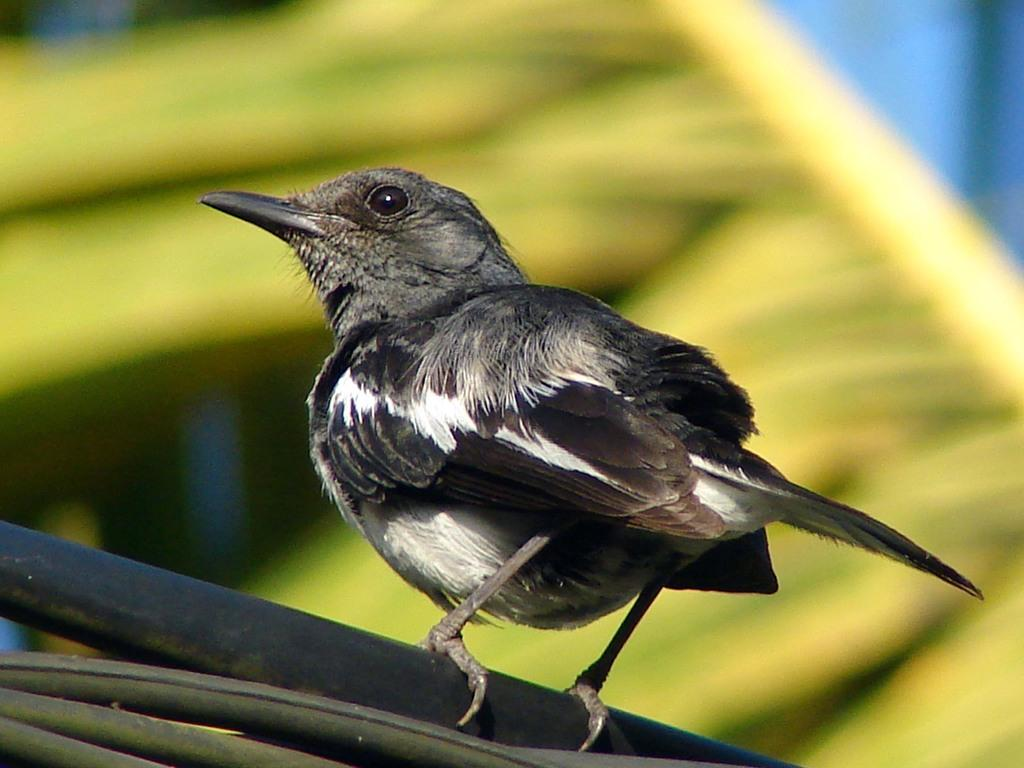What type of animal is in the image? There is a bird in the image. Can you describe the bird's coloring? The bird has white, black, and gray coloring. What can be observed about the background of the image? The background of the image is blurred. How many songs can be heard playing from the tin in the image? There is no tin or songs present in the image; it features a bird with specific coloring and a blurred background. 